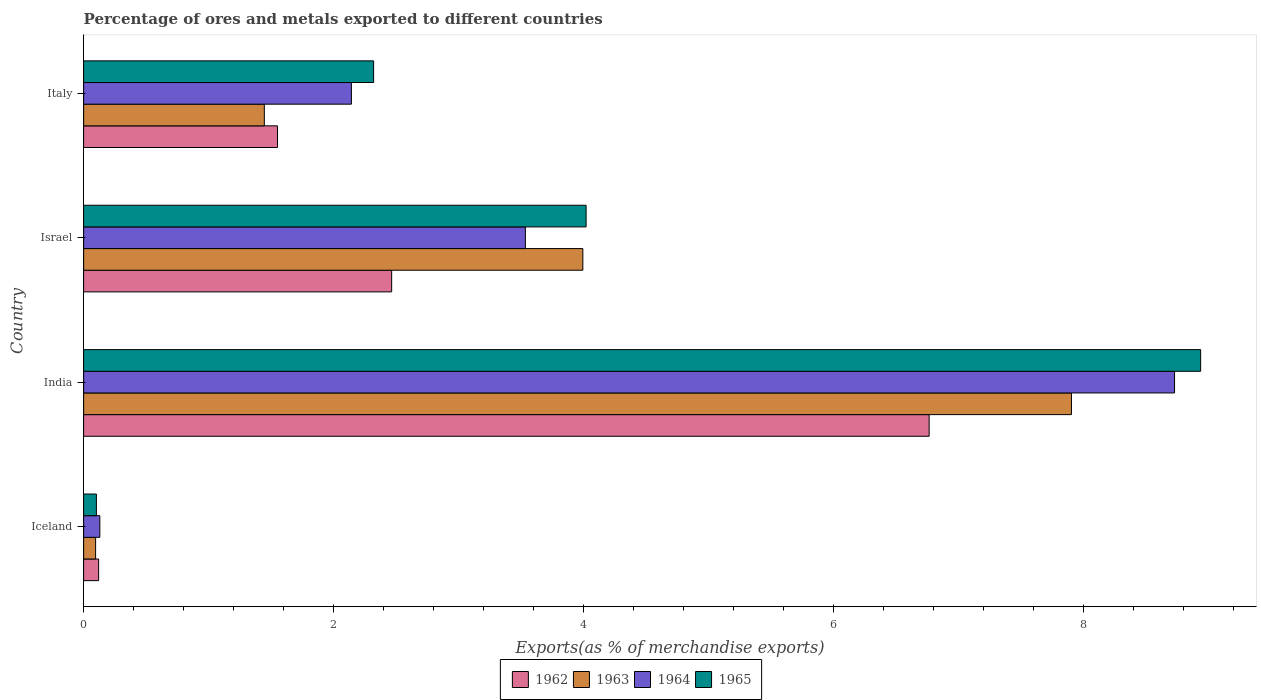How many different coloured bars are there?
Ensure brevity in your answer.  4. Are the number of bars per tick equal to the number of legend labels?
Ensure brevity in your answer.  Yes. How many bars are there on the 1st tick from the top?
Keep it short and to the point. 4. What is the label of the 3rd group of bars from the top?
Your answer should be very brief. India. What is the percentage of exports to different countries in 1962 in India?
Make the answer very short. 6.76. Across all countries, what is the maximum percentage of exports to different countries in 1965?
Ensure brevity in your answer.  8.94. Across all countries, what is the minimum percentage of exports to different countries in 1964?
Offer a very short reply. 0.13. In which country was the percentage of exports to different countries in 1965 minimum?
Provide a succinct answer. Iceland. What is the total percentage of exports to different countries in 1963 in the graph?
Your answer should be compact. 13.44. What is the difference between the percentage of exports to different countries in 1964 in Iceland and that in Italy?
Offer a very short reply. -2.01. What is the difference between the percentage of exports to different countries in 1963 in Italy and the percentage of exports to different countries in 1962 in Iceland?
Provide a short and direct response. 1.33. What is the average percentage of exports to different countries in 1963 per country?
Ensure brevity in your answer.  3.36. What is the difference between the percentage of exports to different countries in 1962 and percentage of exports to different countries in 1965 in Israel?
Offer a terse response. -1.56. What is the ratio of the percentage of exports to different countries in 1963 in Iceland to that in Italy?
Make the answer very short. 0.07. Is the percentage of exports to different countries in 1964 in Israel less than that in Italy?
Give a very brief answer. No. What is the difference between the highest and the second highest percentage of exports to different countries in 1962?
Provide a short and direct response. 4.3. What is the difference between the highest and the lowest percentage of exports to different countries in 1965?
Your answer should be very brief. 8.83. Is the sum of the percentage of exports to different countries in 1965 in India and Italy greater than the maximum percentage of exports to different countries in 1964 across all countries?
Provide a succinct answer. Yes. Is it the case that in every country, the sum of the percentage of exports to different countries in 1965 and percentage of exports to different countries in 1963 is greater than the sum of percentage of exports to different countries in 1962 and percentage of exports to different countries in 1964?
Keep it short and to the point. No. What does the 4th bar from the bottom in India represents?
Keep it short and to the point. 1965. Is it the case that in every country, the sum of the percentage of exports to different countries in 1962 and percentage of exports to different countries in 1965 is greater than the percentage of exports to different countries in 1964?
Give a very brief answer. Yes. How many bars are there?
Provide a short and direct response. 16. How many countries are there in the graph?
Your answer should be very brief. 4. What is the difference between two consecutive major ticks on the X-axis?
Provide a short and direct response. 2. Does the graph contain any zero values?
Your response must be concise. No. How many legend labels are there?
Make the answer very short. 4. How are the legend labels stacked?
Your answer should be very brief. Horizontal. What is the title of the graph?
Your response must be concise. Percentage of ores and metals exported to different countries. Does "1975" appear as one of the legend labels in the graph?
Offer a very short reply. No. What is the label or title of the X-axis?
Provide a short and direct response. Exports(as % of merchandise exports). What is the label or title of the Y-axis?
Provide a succinct answer. Country. What is the Exports(as % of merchandise exports) in 1962 in Iceland?
Offer a terse response. 0.12. What is the Exports(as % of merchandise exports) in 1963 in Iceland?
Make the answer very short. 0.1. What is the Exports(as % of merchandise exports) in 1964 in Iceland?
Keep it short and to the point. 0.13. What is the Exports(as % of merchandise exports) of 1965 in Iceland?
Give a very brief answer. 0.1. What is the Exports(as % of merchandise exports) of 1962 in India?
Your response must be concise. 6.76. What is the Exports(as % of merchandise exports) in 1963 in India?
Make the answer very short. 7.9. What is the Exports(as % of merchandise exports) in 1964 in India?
Offer a terse response. 8.73. What is the Exports(as % of merchandise exports) of 1965 in India?
Your answer should be very brief. 8.94. What is the Exports(as % of merchandise exports) of 1962 in Israel?
Keep it short and to the point. 2.46. What is the Exports(as % of merchandise exports) in 1963 in Israel?
Your response must be concise. 3.99. What is the Exports(as % of merchandise exports) of 1964 in Israel?
Your response must be concise. 3.53. What is the Exports(as % of merchandise exports) of 1965 in Israel?
Give a very brief answer. 4.02. What is the Exports(as % of merchandise exports) in 1962 in Italy?
Provide a succinct answer. 1.55. What is the Exports(as % of merchandise exports) in 1963 in Italy?
Provide a succinct answer. 1.45. What is the Exports(as % of merchandise exports) in 1964 in Italy?
Make the answer very short. 2.14. What is the Exports(as % of merchandise exports) in 1965 in Italy?
Offer a very short reply. 2.32. Across all countries, what is the maximum Exports(as % of merchandise exports) in 1962?
Your answer should be compact. 6.76. Across all countries, what is the maximum Exports(as % of merchandise exports) of 1963?
Your answer should be very brief. 7.9. Across all countries, what is the maximum Exports(as % of merchandise exports) of 1964?
Offer a terse response. 8.73. Across all countries, what is the maximum Exports(as % of merchandise exports) in 1965?
Your response must be concise. 8.94. Across all countries, what is the minimum Exports(as % of merchandise exports) in 1962?
Offer a very short reply. 0.12. Across all countries, what is the minimum Exports(as % of merchandise exports) in 1963?
Make the answer very short. 0.1. Across all countries, what is the minimum Exports(as % of merchandise exports) in 1964?
Your answer should be compact. 0.13. Across all countries, what is the minimum Exports(as % of merchandise exports) in 1965?
Keep it short and to the point. 0.1. What is the total Exports(as % of merchandise exports) in 1962 in the graph?
Provide a short and direct response. 10.9. What is the total Exports(as % of merchandise exports) of 1963 in the graph?
Offer a very short reply. 13.44. What is the total Exports(as % of merchandise exports) of 1964 in the graph?
Provide a succinct answer. 14.53. What is the total Exports(as % of merchandise exports) in 1965 in the graph?
Keep it short and to the point. 15.38. What is the difference between the Exports(as % of merchandise exports) in 1962 in Iceland and that in India?
Keep it short and to the point. -6.64. What is the difference between the Exports(as % of merchandise exports) of 1963 in Iceland and that in India?
Make the answer very short. -7.81. What is the difference between the Exports(as % of merchandise exports) of 1964 in Iceland and that in India?
Give a very brief answer. -8.6. What is the difference between the Exports(as % of merchandise exports) of 1965 in Iceland and that in India?
Your answer should be very brief. -8.83. What is the difference between the Exports(as % of merchandise exports) of 1962 in Iceland and that in Israel?
Give a very brief answer. -2.34. What is the difference between the Exports(as % of merchandise exports) in 1963 in Iceland and that in Israel?
Your answer should be very brief. -3.9. What is the difference between the Exports(as % of merchandise exports) in 1964 in Iceland and that in Israel?
Your answer should be compact. -3.4. What is the difference between the Exports(as % of merchandise exports) of 1965 in Iceland and that in Israel?
Keep it short and to the point. -3.92. What is the difference between the Exports(as % of merchandise exports) of 1962 in Iceland and that in Italy?
Your response must be concise. -1.43. What is the difference between the Exports(as % of merchandise exports) in 1963 in Iceland and that in Italy?
Your response must be concise. -1.35. What is the difference between the Exports(as % of merchandise exports) in 1964 in Iceland and that in Italy?
Make the answer very short. -2.01. What is the difference between the Exports(as % of merchandise exports) of 1965 in Iceland and that in Italy?
Your answer should be very brief. -2.22. What is the difference between the Exports(as % of merchandise exports) in 1962 in India and that in Israel?
Give a very brief answer. 4.3. What is the difference between the Exports(as % of merchandise exports) in 1963 in India and that in Israel?
Give a very brief answer. 3.91. What is the difference between the Exports(as % of merchandise exports) in 1964 in India and that in Israel?
Your answer should be very brief. 5.19. What is the difference between the Exports(as % of merchandise exports) in 1965 in India and that in Israel?
Offer a terse response. 4.92. What is the difference between the Exports(as % of merchandise exports) in 1962 in India and that in Italy?
Offer a terse response. 5.21. What is the difference between the Exports(as % of merchandise exports) in 1963 in India and that in Italy?
Offer a terse response. 6.46. What is the difference between the Exports(as % of merchandise exports) in 1964 in India and that in Italy?
Your answer should be compact. 6.58. What is the difference between the Exports(as % of merchandise exports) in 1965 in India and that in Italy?
Provide a short and direct response. 6.62. What is the difference between the Exports(as % of merchandise exports) in 1962 in Israel and that in Italy?
Offer a very short reply. 0.91. What is the difference between the Exports(as % of merchandise exports) of 1963 in Israel and that in Italy?
Offer a terse response. 2.55. What is the difference between the Exports(as % of merchandise exports) in 1964 in Israel and that in Italy?
Your answer should be very brief. 1.39. What is the difference between the Exports(as % of merchandise exports) in 1965 in Israel and that in Italy?
Provide a short and direct response. 1.7. What is the difference between the Exports(as % of merchandise exports) of 1962 in Iceland and the Exports(as % of merchandise exports) of 1963 in India?
Ensure brevity in your answer.  -7.78. What is the difference between the Exports(as % of merchandise exports) of 1962 in Iceland and the Exports(as % of merchandise exports) of 1964 in India?
Make the answer very short. -8.61. What is the difference between the Exports(as % of merchandise exports) in 1962 in Iceland and the Exports(as % of merchandise exports) in 1965 in India?
Make the answer very short. -8.82. What is the difference between the Exports(as % of merchandise exports) of 1963 in Iceland and the Exports(as % of merchandise exports) of 1964 in India?
Provide a succinct answer. -8.63. What is the difference between the Exports(as % of merchandise exports) in 1963 in Iceland and the Exports(as % of merchandise exports) in 1965 in India?
Offer a very short reply. -8.84. What is the difference between the Exports(as % of merchandise exports) in 1964 in Iceland and the Exports(as % of merchandise exports) in 1965 in India?
Your response must be concise. -8.81. What is the difference between the Exports(as % of merchandise exports) in 1962 in Iceland and the Exports(as % of merchandise exports) in 1963 in Israel?
Offer a very short reply. -3.87. What is the difference between the Exports(as % of merchandise exports) in 1962 in Iceland and the Exports(as % of merchandise exports) in 1964 in Israel?
Give a very brief answer. -3.41. What is the difference between the Exports(as % of merchandise exports) in 1962 in Iceland and the Exports(as % of merchandise exports) in 1965 in Israel?
Offer a terse response. -3.9. What is the difference between the Exports(as % of merchandise exports) in 1963 in Iceland and the Exports(as % of merchandise exports) in 1964 in Israel?
Your answer should be compact. -3.44. What is the difference between the Exports(as % of merchandise exports) in 1963 in Iceland and the Exports(as % of merchandise exports) in 1965 in Israel?
Your answer should be compact. -3.92. What is the difference between the Exports(as % of merchandise exports) in 1964 in Iceland and the Exports(as % of merchandise exports) in 1965 in Israel?
Provide a succinct answer. -3.89. What is the difference between the Exports(as % of merchandise exports) in 1962 in Iceland and the Exports(as % of merchandise exports) in 1963 in Italy?
Provide a succinct answer. -1.33. What is the difference between the Exports(as % of merchandise exports) in 1962 in Iceland and the Exports(as % of merchandise exports) in 1964 in Italy?
Offer a terse response. -2.02. What is the difference between the Exports(as % of merchandise exports) of 1962 in Iceland and the Exports(as % of merchandise exports) of 1965 in Italy?
Your response must be concise. -2.2. What is the difference between the Exports(as % of merchandise exports) in 1963 in Iceland and the Exports(as % of merchandise exports) in 1964 in Italy?
Keep it short and to the point. -2.05. What is the difference between the Exports(as % of merchandise exports) in 1963 in Iceland and the Exports(as % of merchandise exports) in 1965 in Italy?
Offer a very short reply. -2.22. What is the difference between the Exports(as % of merchandise exports) in 1964 in Iceland and the Exports(as % of merchandise exports) in 1965 in Italy?
Your answer should be very brief. -2.19. What is the difference between the Exports(as % of merchandise exports) of 1962 in India and the Exports(as % of merchandise exports) of 1963 in Israel?
Keep it short and to the point. 2.77. What is the difference between the Exports(as % of merchandise exports) of 1962 in India and the Exports(as % of merchandise exports) of 1964 in Israel?
Your answer should be very brief. 3.23. What is the difference between the Exports(as % of merchandise exports) of 1962 in India and the Exports(as % of merchandise exports) of 1965 in Israel?
Make the answer very short. 2.74. What is the difference between the Exports(as % of merchandise exports) of 1963 in India and the Exports(as % of merchandise exports) of 1964 in Israel?
Your answer should be very brief. 4.37. What is the difference between the Exports(as % of merchandise exports) of 1963 in India and the Exports(as % of merchandise exports) of 1965 in Israel?
Offer a very short reply. 3.88. What is the difference between the Exports(as % of merchandise exports) in 1964 in India and the Exports(as % of merchandise exports) in 1965 in Israel?
Give a very brief answer. 4.71. What is the difference between the Exports(as % of merchandise exports) in 1962 in India and the Exports(as % of merchandise exports) in 1963 in Italy?
Your answer should be compact. 5.32. What is the difference between the Exports(as % of merchandise exports) in 1962 in India and the Exports(as % of merchandise exports) in 1964 in Italy?
Offer a terse response. 4.62. What is the difference between the Exports(as % of merchandise exports) in 1962 in India and the Exports(as % of merchandise exports) in 1965 in Italy?
Offer a terse response. 4.44. What is the difference between the Exports(as % of merchandise exports) in 1963 in India and the Exports(as % of merchandise exports) in 1964 in Italy?
Make the answer very short. 5.76. What is the difference between the Exports(as % of merchandise exports) of 1963 in India and the Exports(as % of merchandise exports) of 1965 in Italy?
Offer a very short reply. 5.58. What is the difference between the Exports(as % of merchandise exports) of 1964 in India and the Exports(as % of merchandise exports) of 1965 in Italy?
Provide a short and direct response. 6.41. What is the difference between the Exports(as % of merchandise exports) of 1962 in Israel and the Exports(as % of merchandise exports) of 1963 in Italy?
Give a very brief answer. 1.02. What is the difference between the Exports(as % of merchandise exports) in 1962 in Israel and the Exports(as % of merchandise exports) in 1964 in Italy?
Ensure brevity in your answer.  0.32. What is the difference between the Exports(as % of merchandise exports) in 1962 in Israel and the Exports(as % of merchandise exports) in 1965 in Italy?
Offer a terse response. 0.14. What is the difference between the Exports(as % of merchandise exports) in 1963 in Israel and the Exports(as % of merchandise exports) in 1964 in Italy?
Offer a terse response. 1.85. What is the difference between the Exports(as % of merchandise exports) of 1963 in Israel and the Exports(as % of merchandise exports) of 1965 in Italy?
Your answer should be very brief. 1.67. What is the difference between the Exports(as % of merchandise exports) of 1964 in Israel and the Exports(as % of merchandise exports) of 1965 in Italy?
Keep it short and to the point. 1.21. What is the average Exports(as % of merchandise exports) of 1962 per country?
Offer a terse response. 2.72. What is the average Exports(as % of merchandise exports) in 1963 per country?
Make the answer very short. 3.36. What is the average Exports(as % of merchandise exports) in 1964 per country?
Give a very brief answer. 3.63. What is the average Exports(as % of merchandise exports) of 1965 per country?
Keep it short and to the point. 3.84. What is the difference between the Exports(as % of merchandise exports) in 1962 and Exports(as % of merchandise exports) in 1963 in Iceland?
Offer a very short reply. 0.02. What is the difference between the Exports(as % of merchandise exports) in 1962 and Exports(as % of merchandise exports) in 1964 in Iceland?
Provide a succinct answer. -0.01. What is the difference between the Exports(as % of merchandise exports) of 1962 and Exports(as % of merchandise exports) of 1965 in Iceland?
Provide a succinct answer. 0.02. What is the difference between the Exports(as % of merchandise exports) of 1963 and Exports(as % of merchandise exports) of 1964 in Iceland?
Your answer should be compact. -0.03. What is the difference between the Exports(as % of merchandise exports) of 1963 and Exports(as % of merchandise exports) of 1965 in Iceland?
Provide a short and direct response. -0.01. What is the difference between the Exports(as % of merchandise exports) in 1964 and Exports(as % of merchandise exports) in 1965 in Iceland?
Offer a very short reply. 0.03. What is the difference between the Exports(as % of merchandise exports) of 1962 and Exports(as % of merchandise exports) of 1963 in India?
Keep it short and to the point. -1.14. What is the difference between the Exports(as % of merchandise exports) in 1962 and Exports(as % of merchandise exports) in 1964 in India?
Provide a short and direct response. -1.96. What is the difference between the Exports(as % of merchandise exports) in 1962 and Exports(as % of merchandise exports) in 1965 in India?
Provide a short and direct response. -2.17. What is the difference between the Exports(as % of merchandise exports) in 1963 and Exports(as % of merchandise exports) in 1964 in India?
Offer a very short reply. -0.82. What is the difference between the Exports(as % of merchandise exports) of 1963 and Exports(as % of merchandise exports) of 1965 in India?
Your answer should be compact. -1.03. What is the difference between the Exports(as % of merchandise exports) of 1964 and Exports(as % of merchandise exports) of 1965 in India?
Offer a terse response. -0.21. What is the difference between the Exports(as % of merchandise exports) of 1962 and Exports(as % of merchandise exports) of 1963 in Israel?
Your response must be concise. -1.53. What is the difference between the Exports(as % of merchandise exports) in 1962 and Exports(as % of merchandise exports) in 1964 in Israel?
Provide a succinct answer. -1.07. What is the difference between the Exports(as % of merchandise exports) in 1962 and Exports(as % of merchandise exports) in 1965 in Israel?
Give a very brief answer. -1.56. What is the difference between the Exports(as % of merchandise exports) in 1963 and Exports(as % of merchandise exports) in 1964 in Israel?
Keep it short and to the point. 0.46. What is the difference between the Exports(as % of merchandise exports) of 1963 and Exports(as % of merchandise exports) of 1965 in Israel?
Ensure brevity in your answer.  -0.03. What is the difference between the Exports(as % of merchandise exports) in 1964 and Exports(as % of merchandise exports) in 1965 in Israel?
Keep it short and to the point. -0.49. What is the difference between the Exports(as % of merchandise exports) in 1962 and Exports(as % of merchandise exports) in 1963 in Italy?
Your response must be concise. 0.11. What is the difference between the Exports(as % of merchandise exports) of 1962 and Exports(as % of merchandise exports) of 1964 in Italy?
Offer a very short reply. -0.59. What is the difference between the Exports(as % of merchandise exports) in 1962 and Exports(as % of merchandise exports) in 1965 in Italy?
Give a very brief answer. -0.77. What is the difference between the Exports(as % of merchandise exports) in 1963 and Exports(as % of merchandise exports) in 1964 in Italy?
Give a very brief answer. -0.7. What is the difference between the Exports(as % of merchandise exports) in 1963 and Exports(as % of merchandise exports) in 1965 in Italy?
Your answer should be very brief. -0.87. What is the difference between the Exports(as % of merchandise exports) of 1964 and Exports(as % of merchandise exports) of 1965 in Italy?
Your response must be concise. -0.18. What is the ratio of the Exports(as % of merchandise exports) in 1962 in Iceland to that in India?
Your response must be concise. 0.02. What is the ratio of the Exports(as % of merchandise exports) in 1963 in Iceland to that in India?
Your response must be concise. 0.01. What is the ratio of the Exports(as % of merchandise exports) of 1964 in Iceland to that in India?
Offer a terse response. 0.01. What is the ratio of the Exports(as % of merchandise exports) in 1965 in Iceland to that in India?
Your answer should be compact. 0.01. What is the ratio of the Exports(as % of merchandise exports) of 1962 in Iceland to that in Israel?
Provide a short and direct response. 0.05. What is the ratio of the Exports(as % of merchandise exports) of 1963 in Iceland to that in Israel?
Provide a short and direct response. 0.02. What is the ratio of the Exports(as % of merchandise exports) in 1964 in Iceland to that in Israel?
Your response must be concise. 0.04. What is the ratio of the Exports(as % of merchandise exports) in 1965 in Iceland to that in Israel?
Make the answer very short. 0.03. What is the ratio of the Exports(as % of merchandise exports) in 1962 in Iceland to that in Italy?
Ensure brevity in your answer.  0.08. What is the ratio of the Exports(as % of merchandise exports) in 1963 in Iceland to that in Italy?
Offer a terse response. 0.07. What is the ratio of the Exports(as % of merchandise exports) of 1964 in Iceland to that in Italy?
Offer a very short reply. 0.06. What is the ratio of the Exports(as % of merchandise exports) of 1965 in Iceland to that in Italy?
Provide a short and direct response. 0.04. What is the ratio of the Exports(as % of merchandise exports) of 1962 in India to that in Israel?
Your response must be concise. 2.75. What is the ratio of the Exports(as % of merchandise exports) in 1963 in India to that in Israel?
Keep it short and to the point. 1.98. What is the ratio of the Exports(as % of merchandise exports) of 1964 in India to that in Israel?
Your response must be concise. 2.47. What is the ratio of the Exports(as % of merchandise exports) of 1965 in India to that in Israel?
Give a very brief answer. 2.22. What is the ratio of the Exports(as % of merchandise exports) in 1962 in India to that in Italy?
Offer a terse response. 4.36. What is the ratio of the Exports(as % of merchandise exports) of 1963 in India to that in Italy?
Your answer should be very brief. 5.47. What is the ratio of the Exports(as % of merchandise exports) of 1964 in India to that in Italy?
Ensure brevity in your answer.  4.07. What is the ratio of the Exports(as % of merchandise exports) of 1965 in India to that in Italy?
Provide a succinct answer. 3.85. What is the ratio of the Exports(as % of merchandise exports) in 1962 in Israel to that in Italy?
Make the answer very short. 1.59. What is the ratio of the Exports(as % of merchandise exports) in 1963 in Israel to that in Italy?
Your response must be concise. 2.76. What is the ratio of the Exports(as % of merchandise exports) of 1964 in Israel to that in Italy?
Keep it short and to the point. 1.65. What is the ratio of the Exports(as % of merchandise exports) of 1965 in Israel to that in Italy?
Provide a short and direct response. 1.73. What is the difference between the highest and the second highest Exports(as % of merchandise exports) of 1962?
Your answer should be compact. 4.3. What is the difference between the highest and the second highest Exports(as % of merchandise exports) of 1963?
Ensure brevity in your answer.  3.91. What is the difference between the highest and the second highest Exports(as % of merchandise exports) in 1964?
Give a very brief answer. 5.19. What is the difference between the highest and the second highest Exports(as % of merchandise exports) in 1965?
Keep it short and to the point. 4.92. What is the difference between the highest and the lowest Exports(as % of merchandise exports) of 1962?
Your answer should be compact. 6.64. What is the difference between the highest and the lowest Exports(as % of merchandise exports) of 1963?
Keep it short and to the point. 7.81. What is the difference between the highest and the lowest Exports(as % of merchandise exports) in 1964?
Offer a terse response. 8.6. What is the difference between the highest and the lowest Exports(as % of merchandise exports) of 1965?
Your answer should be compact. 8.83. 